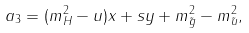<formula> <loc_0><loc_0><loc_500><loc_500>a _ { 3 } = ( m _ { H } ^ { 2 } - u ) x + s y + m ^ { 2 } _ { \tilde { g } } - m ^ { 2 } _ { \tilde { u } } ,</formula> 